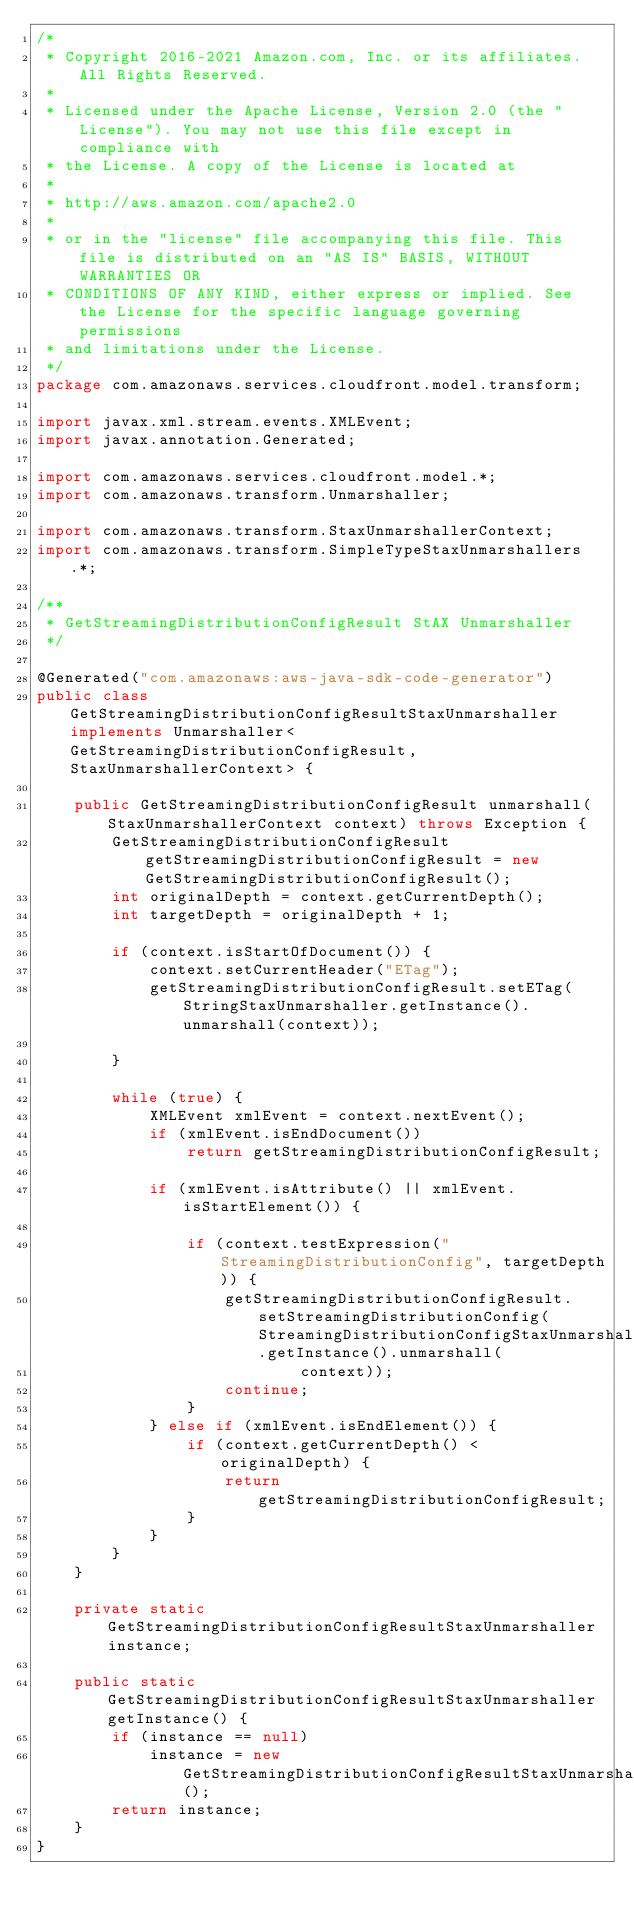<code> <loc_0><loc_0><loc_500><loc_500><_Java_>/*
 * Copyright 2016-2021 Amazon.com, Inc. or its affiliates. All Rights Reserved.
 * 
 * Licensed under the Apache License, Version 2.0 (the "License"). You may not use this file except in compliance with
 * the License. A copy of the License is located at
 * 
 * http://aws.amazon.com/apache2.0
 * 
 * or in the "license" file accompanying this file. This file is distributed on an "AS IS" BASIS, WITHOUT WARRANTIES OR
 * CONDITIONS OF ANY KIND, either express or implied. See the License for the specific language governing permissions
 * and limitations under the License.
 */
package com.amazonaws.services.cloudfront.model.transform;

import javax.xml.stream.events.XMLEvent;
import javax.annotation.Generated;

import com.amazonaws.services.cloudfront.model.*;
import com.amazonaws.transform.Unmarshaller;

import com.amazonaws.transform.StaxUnmarshallerContext;
import com.amazonaws.transform.SimpleTypeStaxUnmarshallers.*;

/**
 * GetStreamingDistributionConfigResult StAX Unmarshaller
 */

@Generated("com.amazonaws:aws-java-sdk-code-generator")
public class GetStreamingDistributionConfigResultStaxUnmarshaller implements Unmarshaller<GetStreamingDistributionConfigResult, StaxUnmarshallerContext> {

    public GetStreamingDistributionConfigResult unmarshall(StaxUnmarshallerContext context) throws Exception {
        GetStreamingDistributionConfigResult getStreamingDistributionConfigResult = new GetStreamingDistributionConfigResult();
        int originalDepth = context.getCurrentDepth();
        int targetDepth = originalDepth + 1;

        if (context.isStartOfDocument()) {
            context.setCurrentHeader("ETag");
            getStreamingDistributionConfigResult.setETag(StringStaxUnmarshaller.getInstance().unmarshall(context));

        }

        while (true) {
            XMLEvent xmlEvent = context.nextEvent();
            if (xmlEvent.isEndDocument())
                return getStreamingDistributionConfigResult;

            if (xmlEvent.isAttribute() || xmlEvent.isStartElement()) {

                if (context.testExpression("StreamingDistributionConfig", targetDepth)) {
                    getStreamingDistributionConfigResult.setStreamingDistributionConfig(StreamingDistributionConfigStaxUnmarshaller.getInstance().unmarshall(
                            context));
                    continue;
                }
            } else if (xmlEvent.isEndElement()) {
                if (context.getCurrentDepth() < originalDepth) {
                    return getStreamingDistributionConfigResult;
                }
            }
        }
    }

    private static GetStreamingDistributionConfigResultStaxUnmarshaller instance;

    public static GetStreamingDistributionConfigResultStaxUnmarshaller getInstance() {
        if (instance == null)
            instance = new GetStreamingDistributionConfigResultStaxUnmarshaller();
        return instance;
    }
}
</code> 